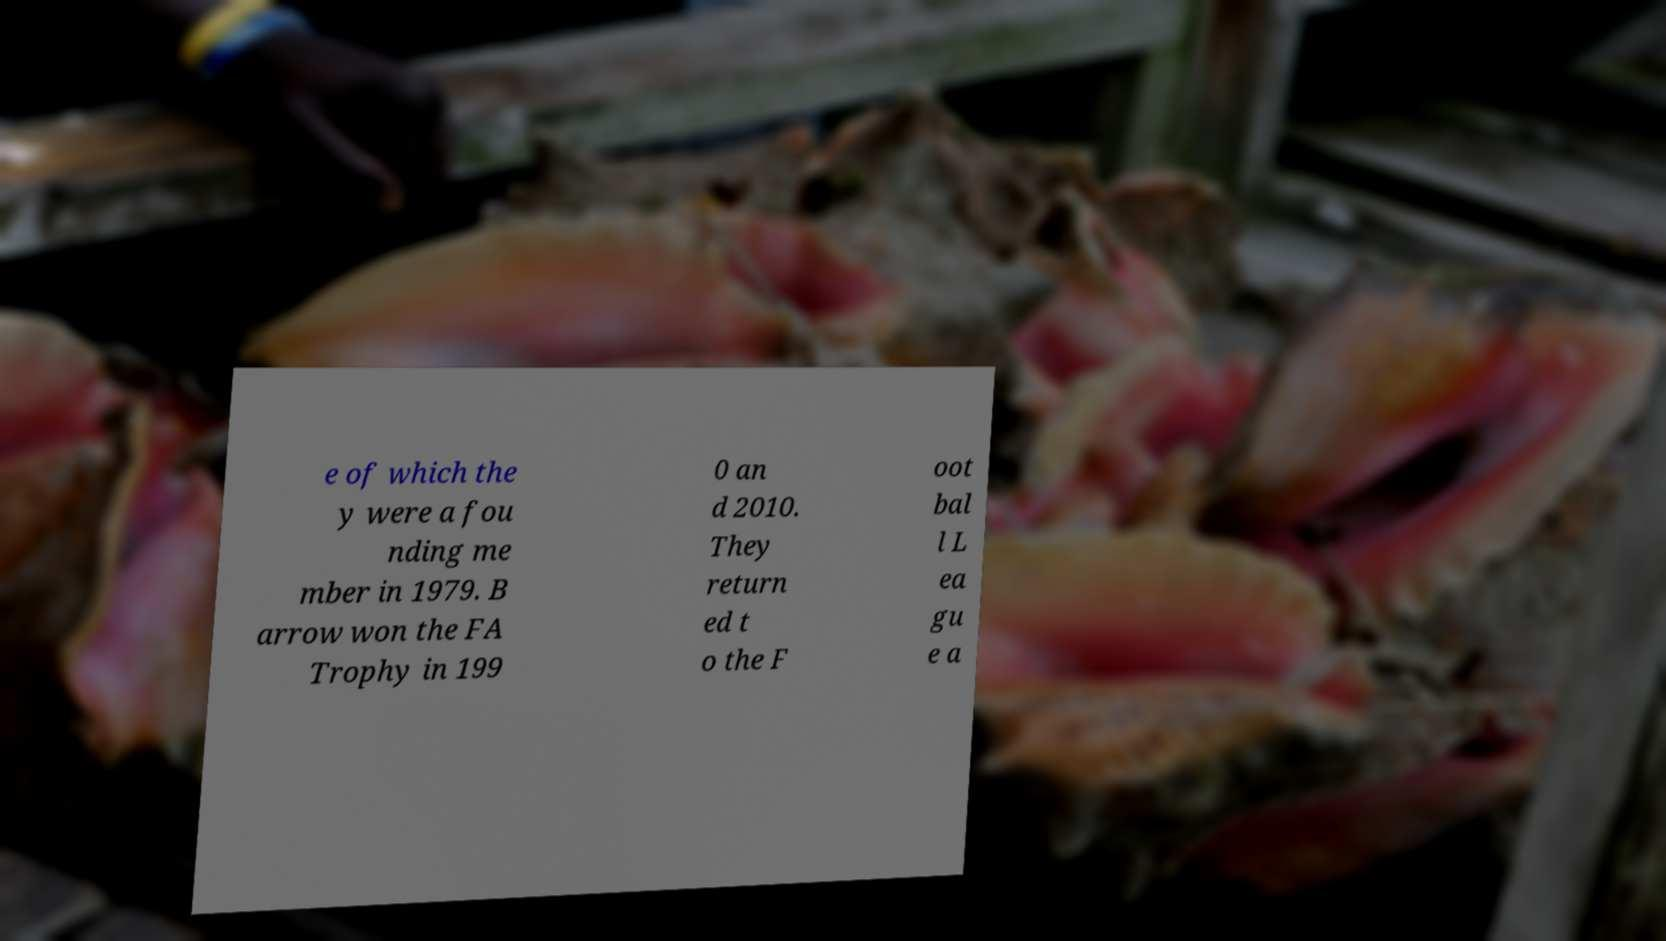Please identify and transcribe the text found in this image. e of which the y were a fou nding me mber in 1979. B arrow won the FA Trophy in 199 0 an d 2010. They return ed t o the F oot bal l L ea gu e a 